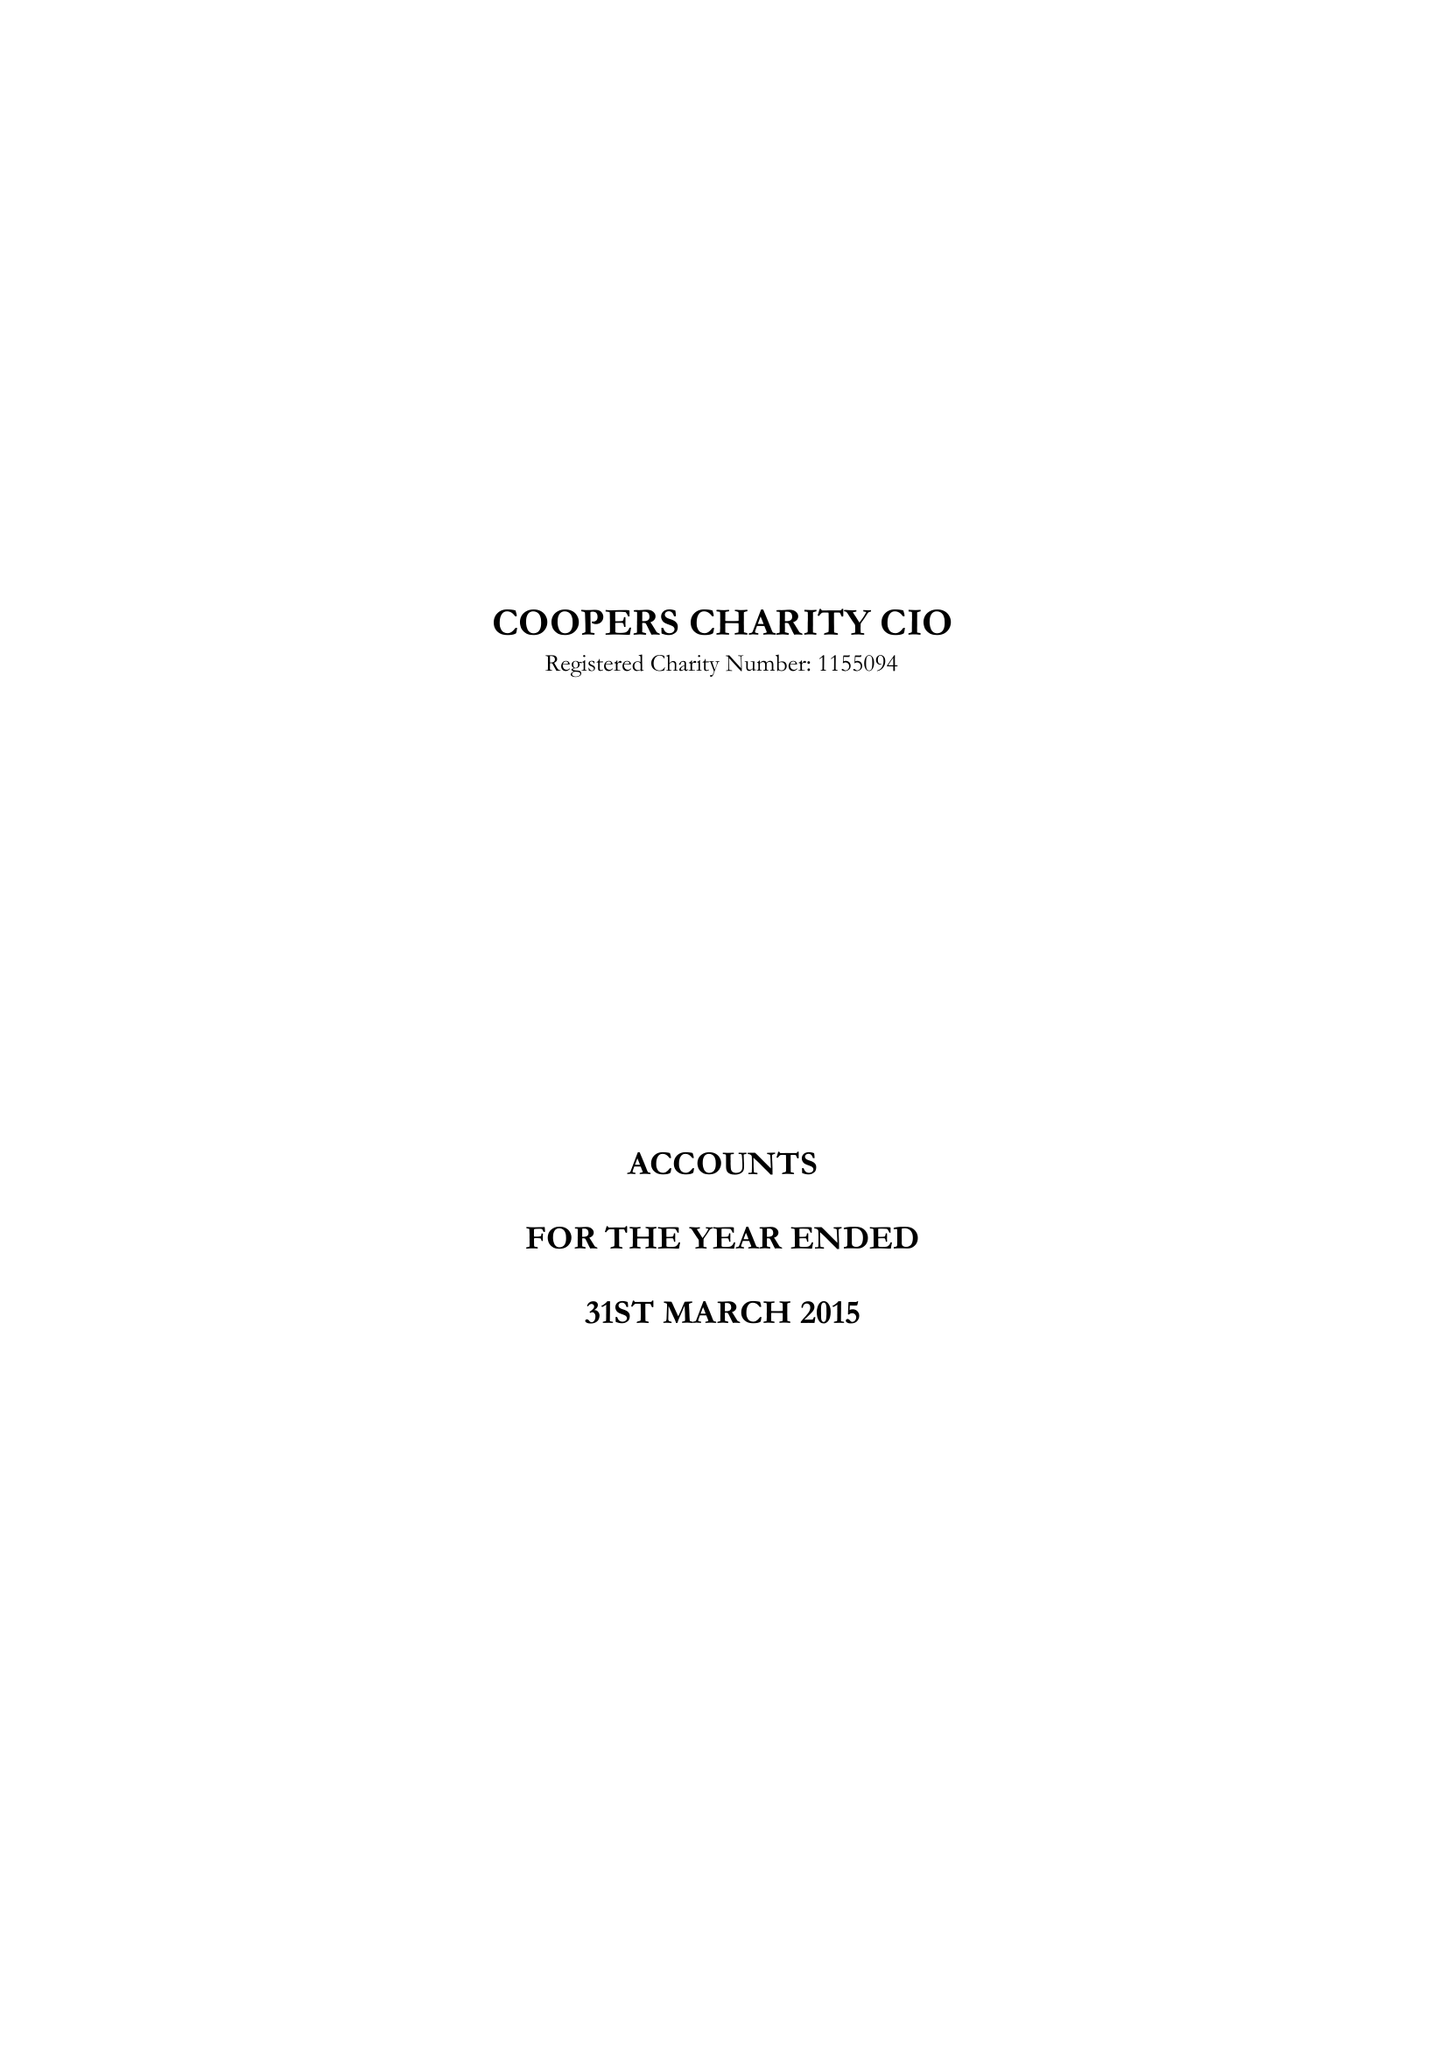What is the value for the spending_annually_in_british_pounds?
Answer the question using a single word or phrase. 206556.00 